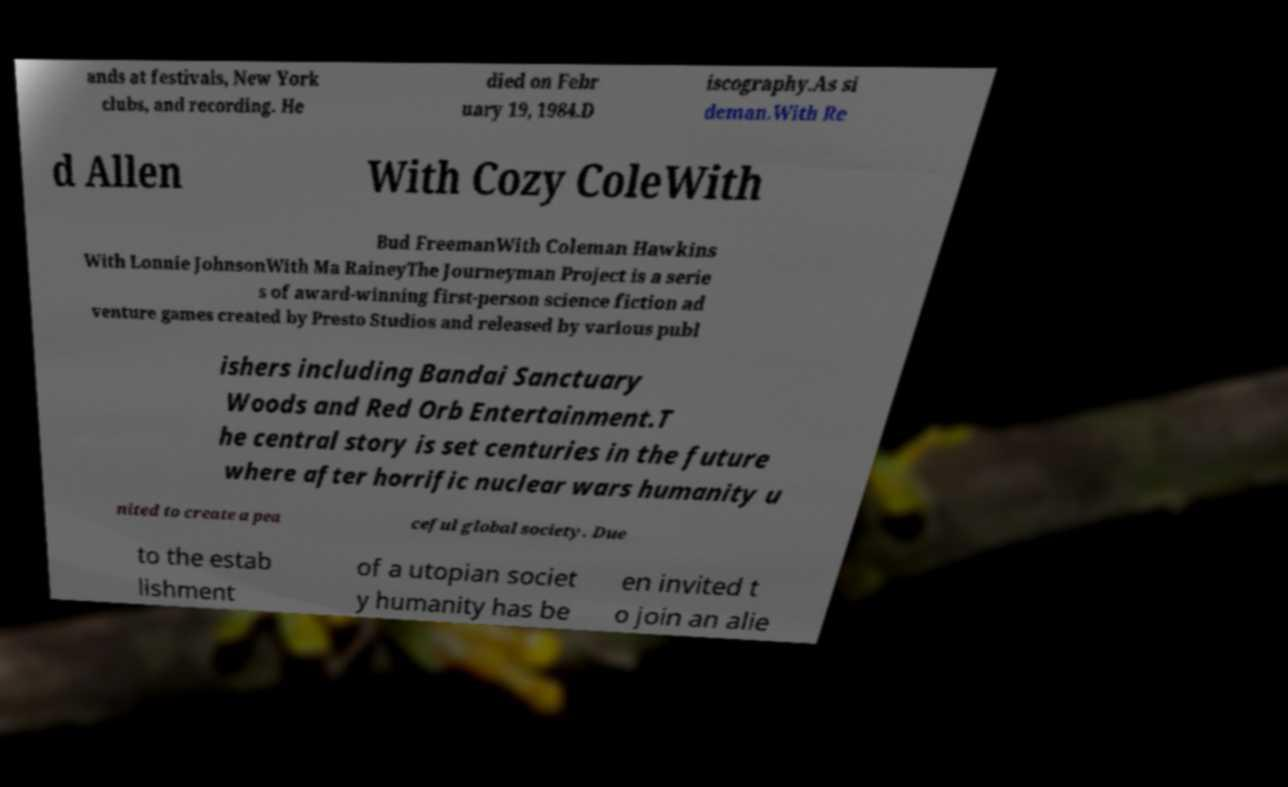Could you extract and type out the text from this image? ands at festivals, New York clubs, and recording. He died on Febr uary 19, 1984.D iscography.As si deman.With Re d Allen With Cozy ColeWith Bud FreemanWith Coleman Hawkins With Lonnie JohnsonWith Ma RaineyThe Journeyman Project is a serie s of award-winning first-person science fiction ad venture games created by Presto Studios and released by various publ ishers including Bandai Sanctuary Woods and Red Orb Entertainment.T he central story is set centuries in the future where after horrific nuclear wars humanity u nited to create a pea ceful global society. Due to the estab lishment of a utopian societ y humanity has be en invited t o join an alie 